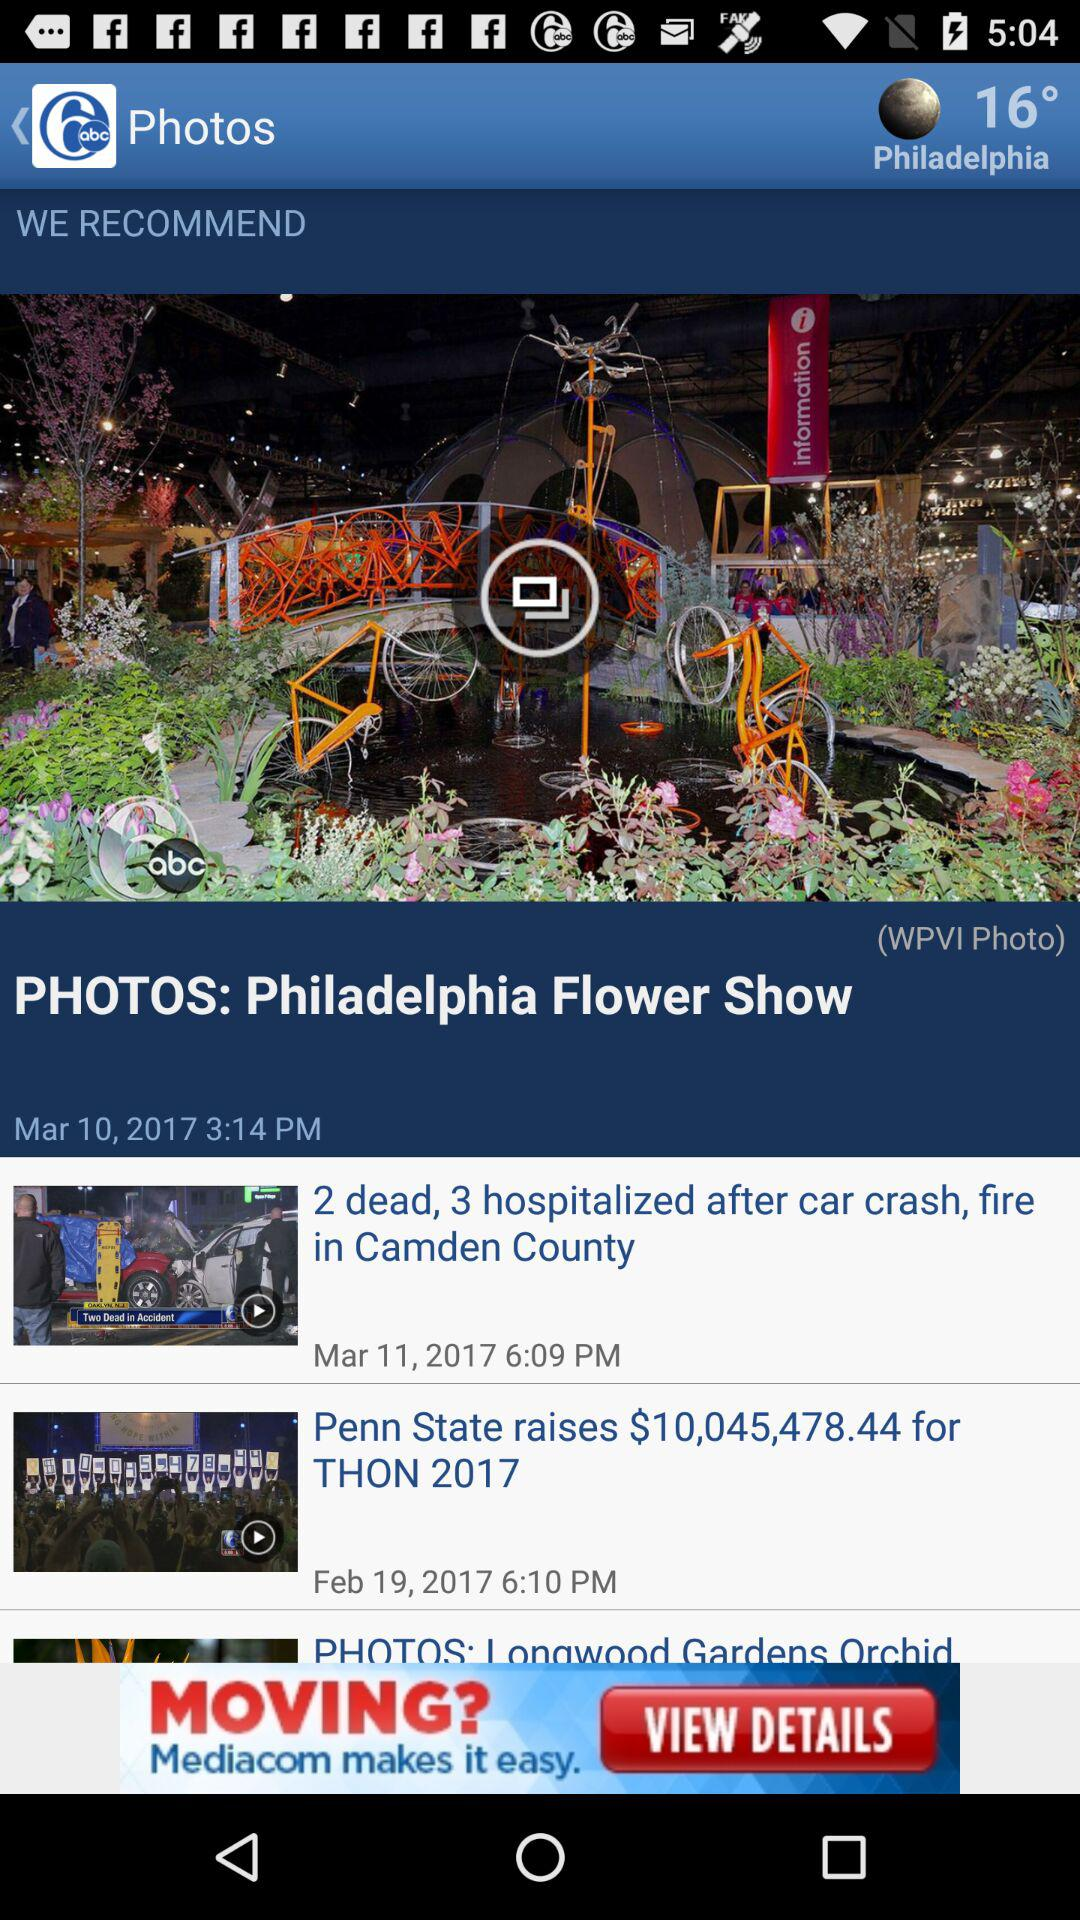What is the location? The location is Philadelphia. 